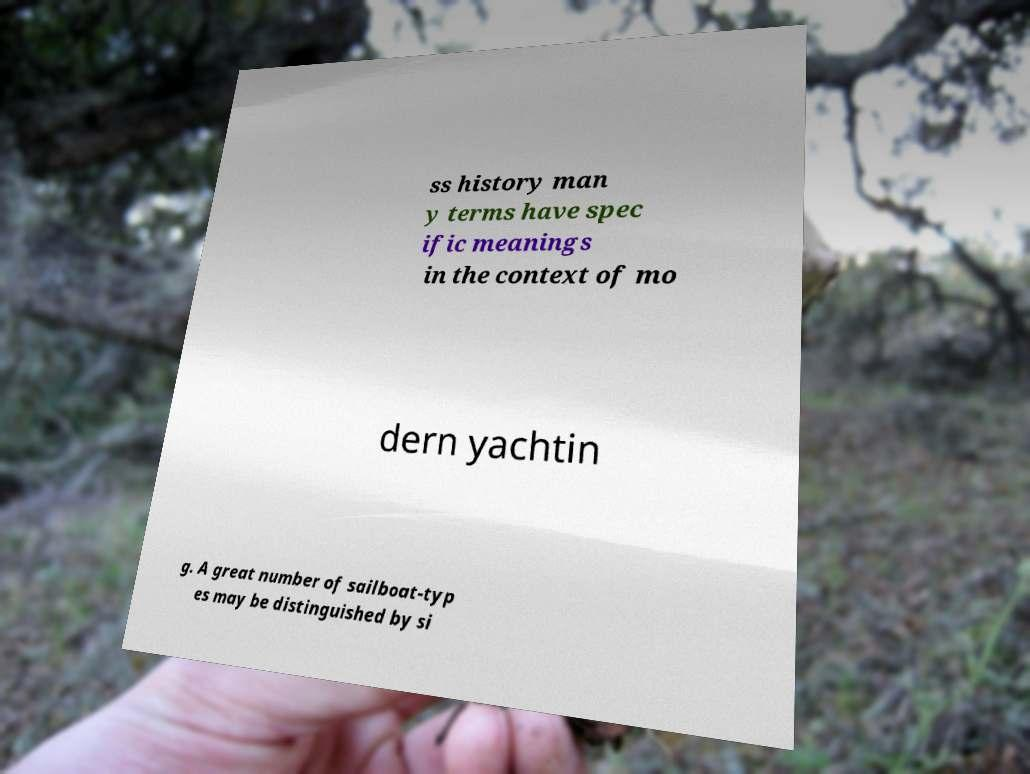I need the written content from this picture converted into text. Can you do that? ss history man y terms have spec ific meanings in the context of mo dern yachtin g. A great number of sailboat-typ es may be distinguished by si 